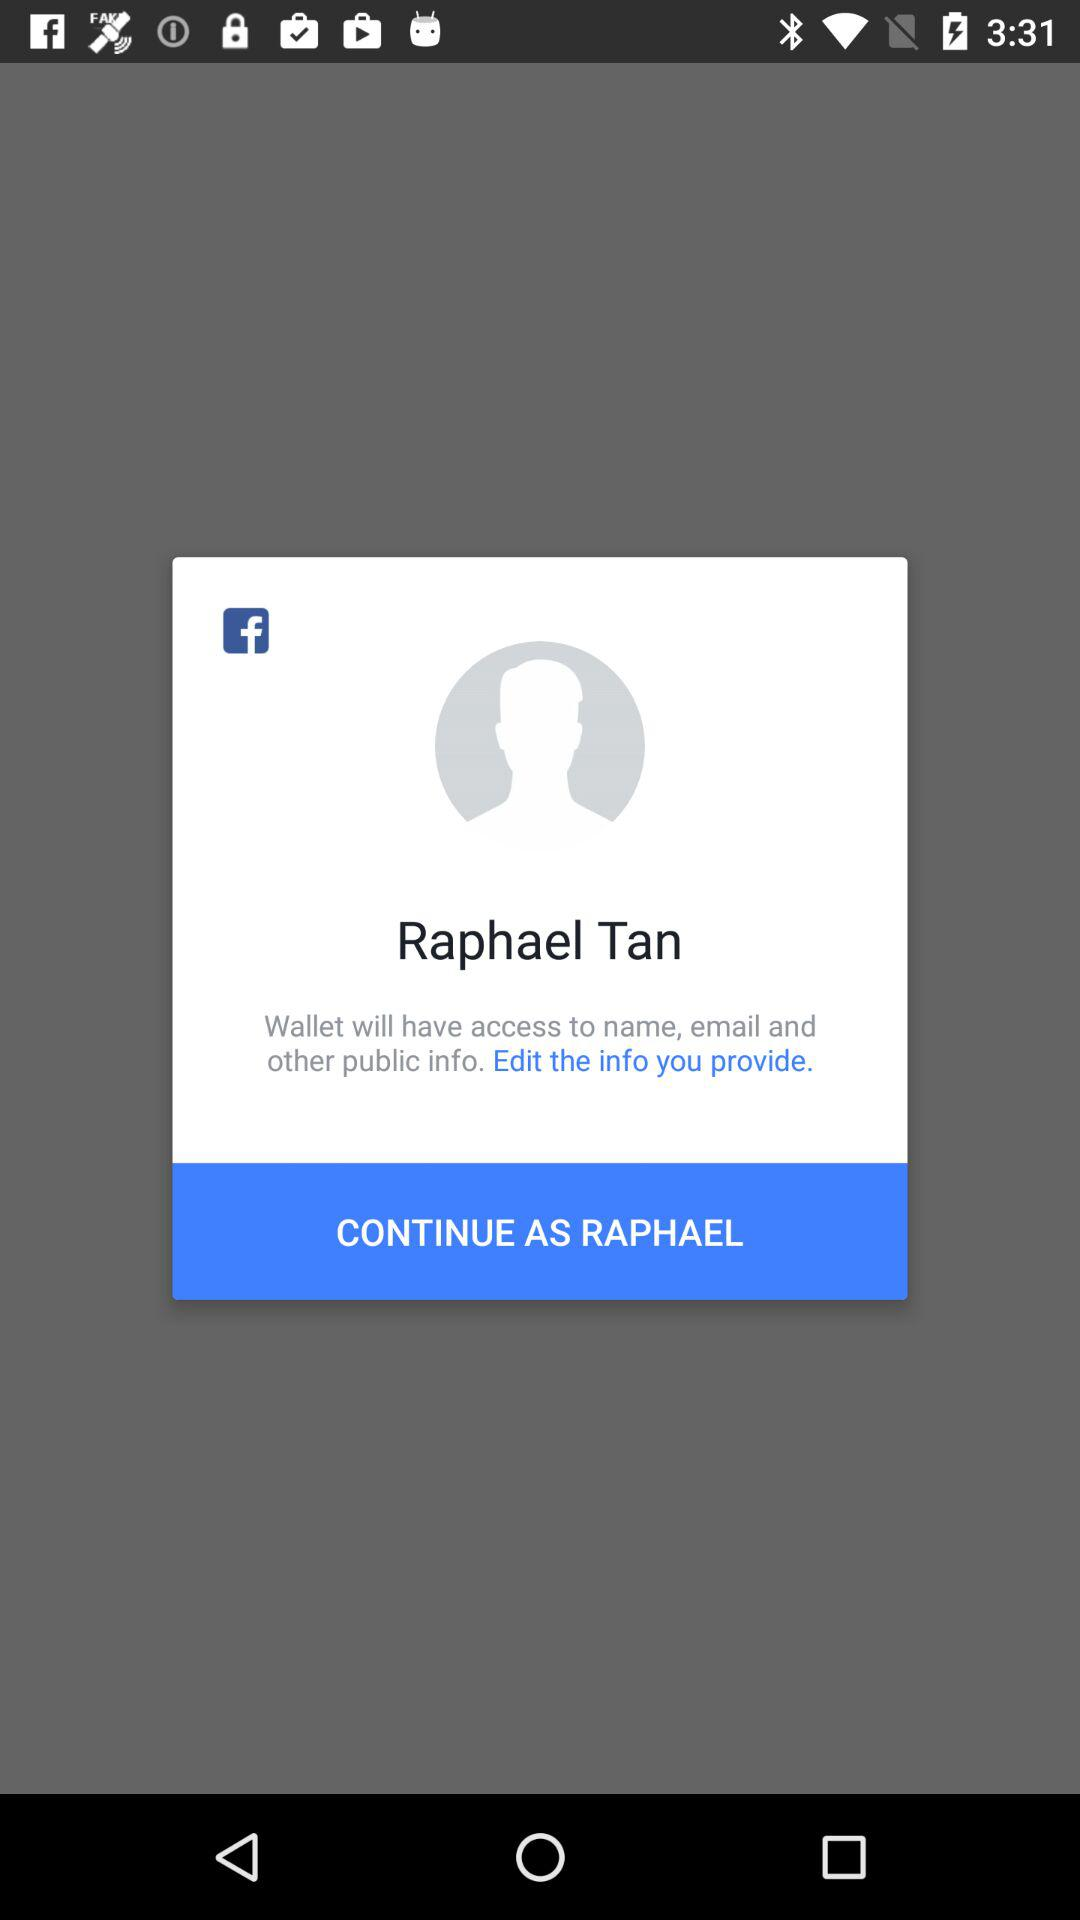What is the name of the user who can continue the application? The name of the user who can continue the application is Raphael Tan. 